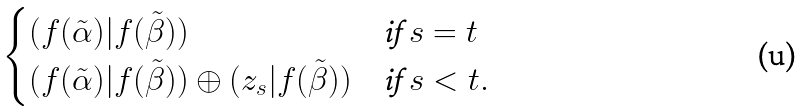Convert formula to latex. <formula><loc_0><loc_0><loc_500><loc_500>\begin{cases} ( f ( \tilde { \alpha } ) | f ( \tilde { \beta } ) ) & \text {if $s=t$} \\ ( f ( \tilde { \alpha } ) | f ( \tilde { \beta } ) ) \oplus ( z _ { s } | f ( \tilde { \beta } ) ) & \text {if $s < t$} . \end{cases}</formula> 